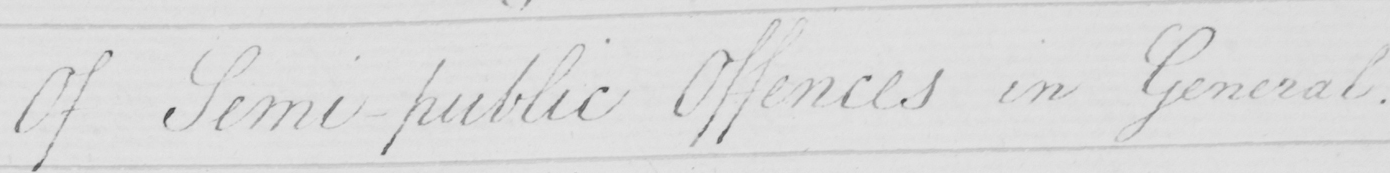Can you read and transcribe this handwriting? Of Semi-public Offences in General . 